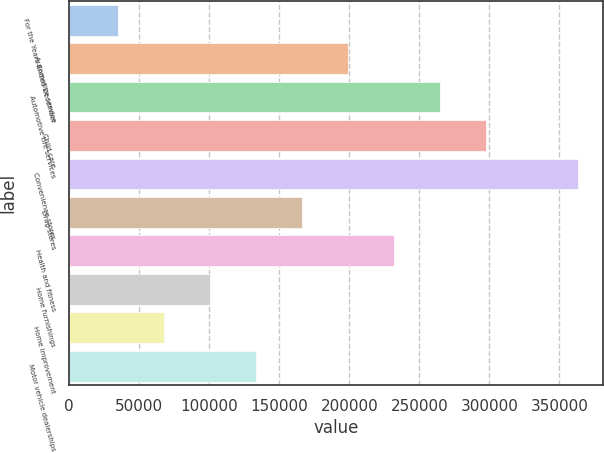Convert chart. <chart><loc_0><loc_0><loc_500><loc_500><bar_chart><fcel>For the Years Ended December<fcel>Automotive service<fcel>Automotive tire services<fcel>Child care<fcel>Convenience stores<fcel>Drug stores<fcel>Health and fitness<fcel>Home furnishings<fcel>Home improvement<fcel>Motor vehicle dealerships<nl><fcel>34760.6<fcel>198894<fcel>264547<fcel>297373<fcel>363027<fcel>166067<fcel>231720<fcel>100414<fcel>67587.2<fcel>133240<nl></chart> 